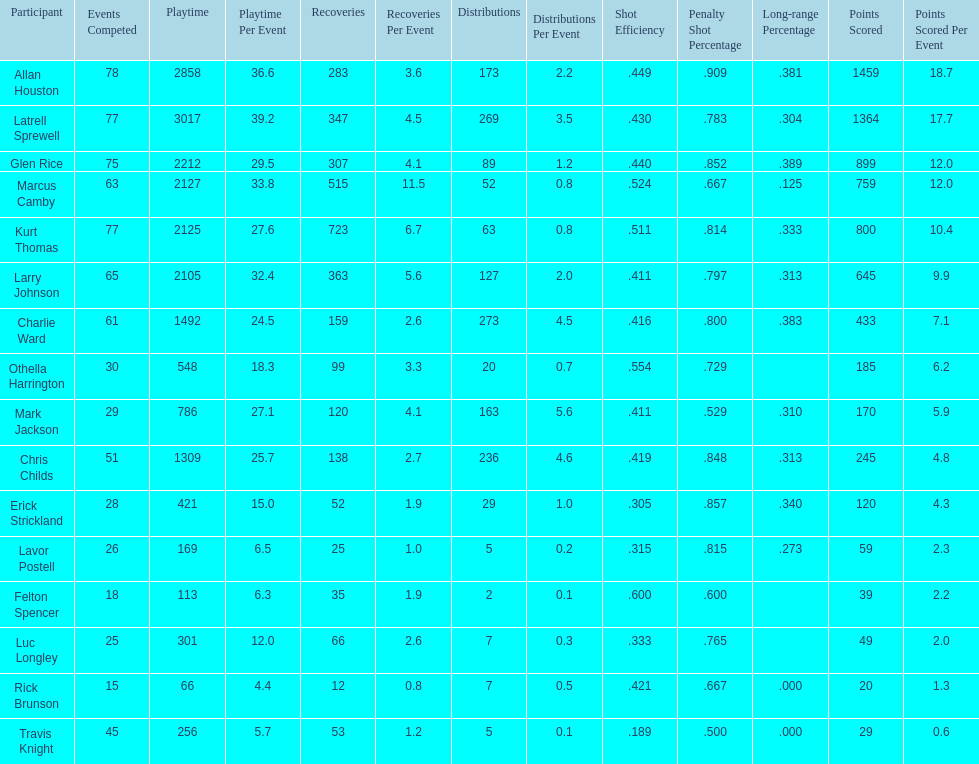How many players had a field goal percentage greater than .500? 4. 